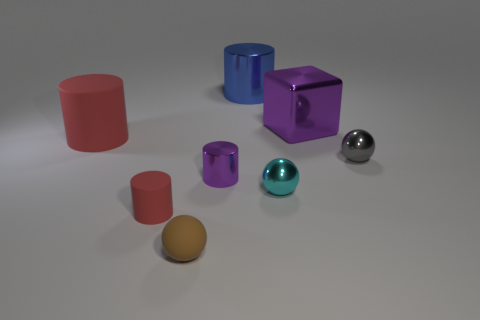What number of purple things have the same size as the purple cylinder?
Make the answer very short. 0. There is a big object that is the same color as the small metallic cylinder; what is its shape?
Your answer should be compact. Cube. What shape is the purple shiny thing that is behind the object on the left side of the small matte object behind the tiny brown rubber object?
Offer a terse response. Cube. There is a tiny sphere that is to the right of the cyan object; what color is it?
Give a very brief answer. Gray. How many things are either small purple cylinders on the right side of the tiny red thing or metal objects that are in front of the purple metal cube?
Your answer should be very brief. 3. What number of other things have the same shape as the large purple thing?
Offer a very short reply. 0. The other shiny sphere that is the same size as the gray shiny ball is what color?
Keep it short and to the point. Cyan. What color is the large metal object that is in front of the big blue cylinder on the right side of the red thing to the left of the small red rubber cylinder?
Offer a very short reply. Purple. Is the size of the brown rubber sphere the same as the red rubber cylinder that is behind the tiny purple metallic thing?
Your answer should be compact. No. How many objects are purple cylinders or big red shiny balls?
Provide a succinct answer. 1. 